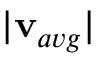<formula> <loc_0><loc_0><loc_500><loc_500>| v _ { a v g } |</formula> 